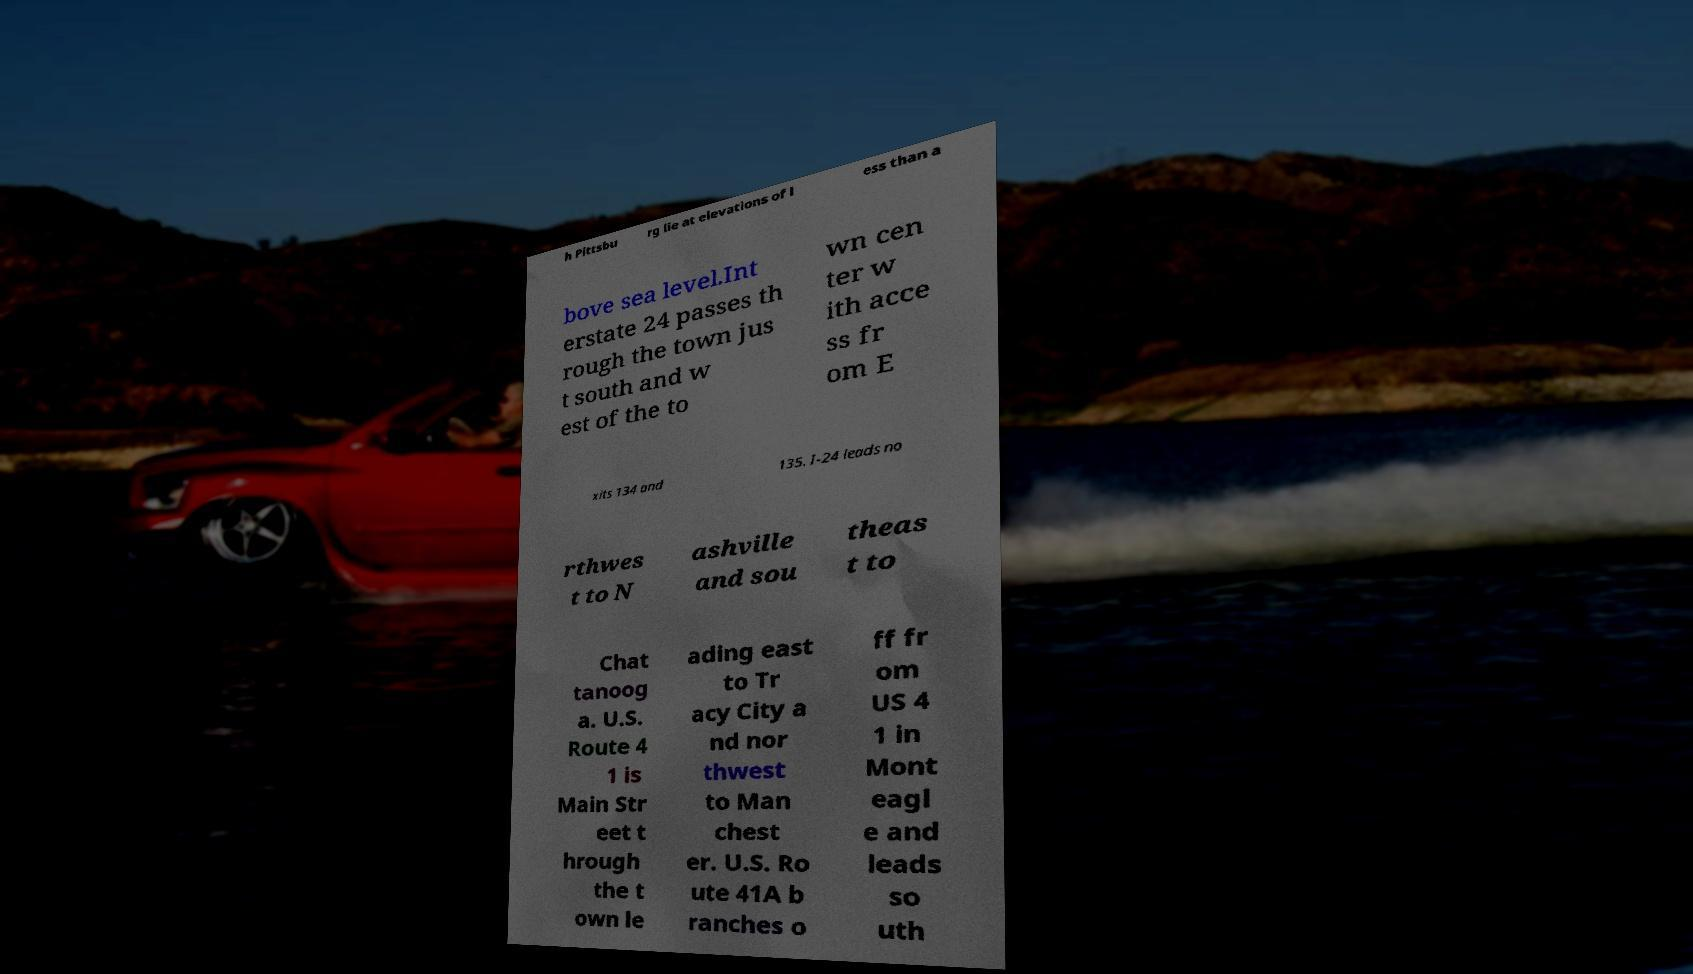What messages or text are displayed in this image? I need them in a readable, typed format. h Pittsbu rg lie at elevations of l ess than a bove sea level.Int erstate 24 passes th rough the town jus t south and w est of the to wn cen ter w ith acce ss fr om E xits 134 and 135. I-24 leads no rthwes t to N ashville and sou theas t to Chat tanoog a. U.S. Route 4 1 is Main Str eet t hrough the t own le ading east to Tr acy City a nd nor thwest to Man chest er. U.S. Ro ute 41A b ranches o ff fr om US 4 1 in Mont eagl e and leads so uth 